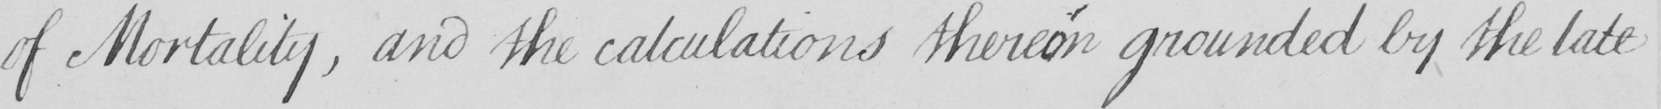Can you read and transcribe this handwriting? of Mortality , and the calculations therein grounded by the late 